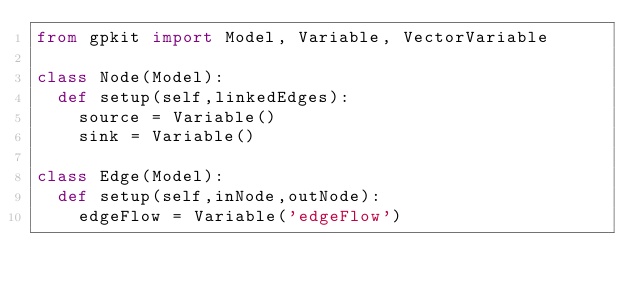<code> <loc_0><loc_0><loc_500><loc_500><_Python_>from gpkit import Model, Variable, VectorVariable

class Node(Model):
	def setup(self,linkedEdges):
		source = Variable()
		sink = Variable()

class Edge(Model):
	def setup(self,inNode,outNode):
		edgeFlow = Variable('edgeFlow')
</code> 